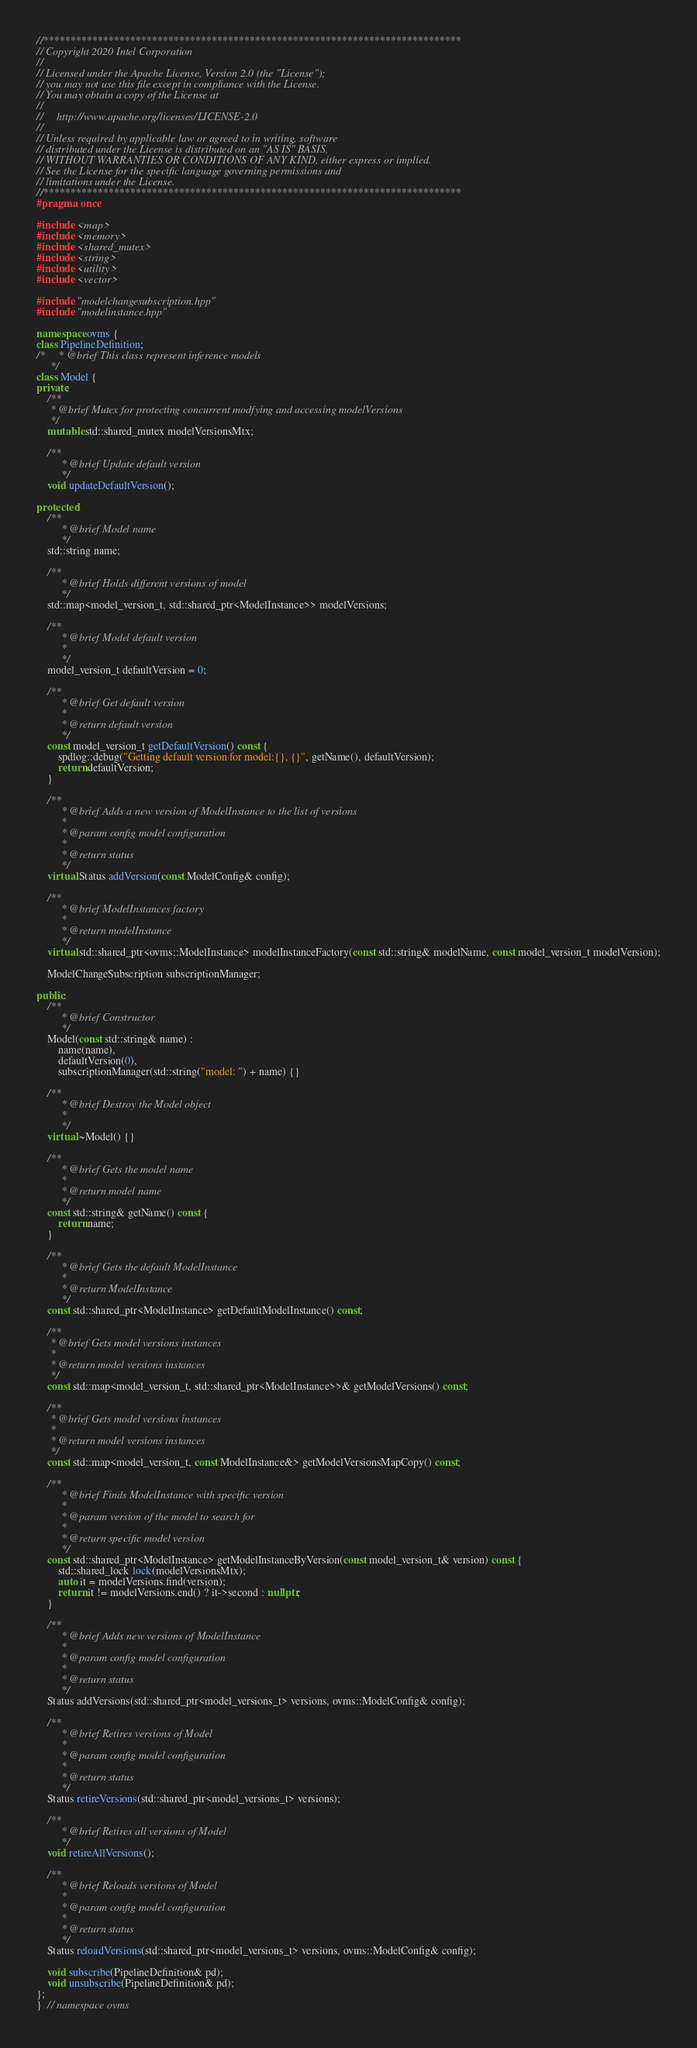<code> <loc_0><loc_0><loc_500><loc_500><_C++_>//*****************************************************************************
// Copyright 2020 Intel Corporation
//
// Licensed under the Apache License, Version 2.0 (the "License");
// you may not use this file except in compliance with the License.
// You may obtain a copy of the License at
//
//     http://www.apache.org/licenses/LICENSE-2.0
//
// Unless required by applicable law or agreed to in writing, software
// distributed under the License is distributed on an "AS IS" BASIS,
// WITHOUT WARRANTIES OR CONDITIONS OF ANY KIND, either express or implied.
// See the License for the specific language governing permissions and
// limitations under the License.
//*****************************************************************************
#pragma once

#include <map>
#include <memory>
#include <shared_mutex>
#include <string>
#include <utility>
#include <vector>

#include "modelchangesubscription.hpp"
#include "modelinstance.hpp"

namespace ovms {
class PipelineDefinition;
/*     * @brief This class represent inference models
     */
class Model {
private:
    /**
     * @brief Mutex for protecting concurrent modfying and accessing modelVersions
     */
    mutable std::shared_mutex modelVersionsMtx;

    /**
         * @brief Update default version
         */
    void updateDefaultVersion();

protected:
    /**
         * @brief Model name
         */
    std::string name;

    /**
         * @brief Holds different versions of model
         */
    std::map<model_version_t, std::shared_ptr<ModelInstance>> modelVersions;

    /**
         * @brief Model default version
         *
         */
    model_version_t defaultVersion = 0;

    /**
         * @brief Get default version
         *
         * @return default version
         */
    const model_version_t getDefaultVersion() const {
        spdlog::debug("Getting default version for model:{}, {}", getName(), defaultVersion);
        return defaultVersion;
    }

    /**
         * @brief Adds a new version of ModelInstance to the list of versions
         *
         * @param config model configuration
         *
         * @return status
         */
    virtual Status addVersion(const ModelConfig& config);

    /**
         * @brief ModelInstances factory
         *
         * @return modelInstance
         */
    virtual std::shared_ptr<ovms::ModelInstance> modelInstanceFactory(const std::string& modelName, const model_version_t modelVersion);

    ModelChangeSubscription subscriptionManager;

public:
    /**
         * @brief Constructor
         */
    Model(const std::string& name) :
        name(name),
        defaultVersion(0),
        subscriptionManager(std::string("model: ") + name) {}

    /**
         * @brief Destroy the Model object
         * 
         */
    virtual ~Model() {}

    /**
         * @brief Gets the model name
         * 
         * @return model name
         */
    const std::string& getName() const {
        return name;
    }

    /**
         * @brief Gets the default ModelInstance
         *
         * @return ModelInstance
         */
    const std::shared_ptr<ModelInstance> getDefaultModelInstance() const;

    /**
     * @brief Gets model versions instances
     *
     * @return model versions instances
     */
    const std::map<model_version_t, std::shared_ptr<ModelInstance>>& getModelVersions() const;

    /**
     * @brief Gets model versions instances
     *
     * @return model versions instances
     */
    const std::map<model_version_t, const ModelInstance&> getModelVersionsMapCopy() const;

    /**
         * @brief Finds ModelInstance with specific version
         *
         * @param version of the model to search for
         *
         * @return specific model version
         */
    const std::shared_ptr<ModelInstance> getModelInstanceByVersion(const model_version_t& version) const {
        std::shared_lock lock(modelVersionsMtx);
        auto it = modelVersions.find(version);
        return it != modelVersions.end() ? it->second : nullptr;
    }

    /**
         * @brief Adds new versions of ModelInstance
         *
         * @param config model configuration
         *
         * @return status
         */
    Status addVersions(std::shared_ptr<model_versions_t> versions, ovms::ModelConfig& config);

    /**
         * @brief Retires versions of Model
         *
         * @param config model configuration
         *
         * @return status
         */
    Status retireVersions(std::shared_ptr<model_versions_t> versions);

    /**
         * @brief Retires all versions of Model
         */
    void retireAllVersions();

    /**
         * @brief Reloads versions of Model
         *
         * @param config model configuration
         *
         * @return status
         */
    Status reloadVersions(std::shared_ptr<model_versions_t> versions, ovms::ModelConfig& config);

    void subscribe(PipelineDefinition& pd);
    void unsubscribe(PipelineDefinition& pd);
};
}  // namespace ovms
</code> 